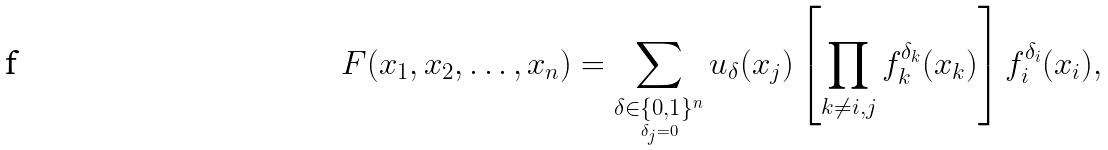Convert formula to latex. <formula><loc_0><loc_0><loc_500><loc_500>F ( x _ { 1 } , x _ { 2 } , \dots , x _ { n } ) = \sum _ { \underset { \delta _ { j } = 0 } { \delta \in \{ 0 , 1 \} ^ { n } } } u _ { \delta } ( x _ { j } ) \left [ \prod _ { k \neq i , j } f _ { k } ^ { \delta _ { k } } ( x _ { k } ) \right ] f _ { i } ^ { \delta _ { i } } ( x _ { i } ) ,</formula> 